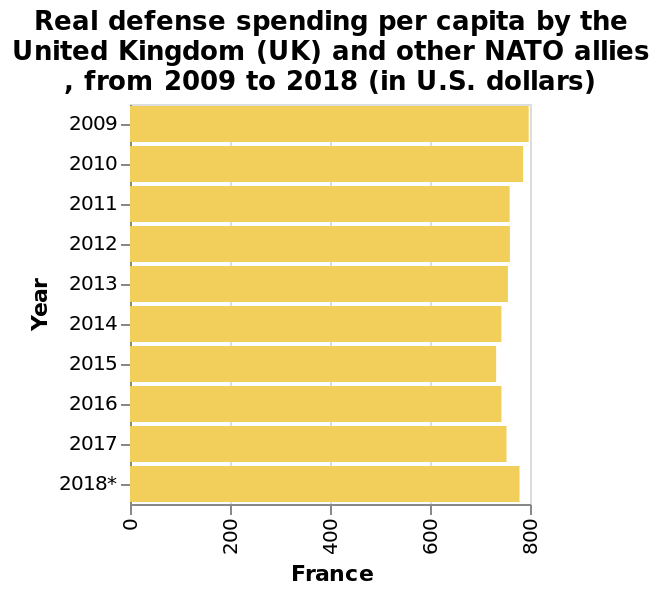<image>
What is the unit of measurement for the real defense spending per capita? The unit of measurement for the real defense spending per capita is U.S. dollars. What was the overall trend of the real defence spending by France between 2009 and 2018? The overall trend of the real defence spending by France between 2009 and 2018 was a gradual decrease followed by a year-on-year increase. What was the approximate amount of the real defence spending by France in 2018? The real defence spending by France in 2018 was nearly 800 dollars. What is measured on the y-axis of the bar plot? The y-axis of the bar plot measures the year. Describe the following image in detail Here a bar plot is titled Real defense spending per capita by the United Kingdom (UK) and other NATO allies , from 2009 to 2018 (in U.S. dollars). The x-axis measures France while the y-axis measures Year. When did the real defence spending by France start to increase after a period of decrease? The real defence spending by France started to increase after a period of decrease from 2009 to 2015. Is a line plot titled Fake defense spending per capita by the United Kingdom (UK) and other NATO allies, from 2009 to 2018 (in U.S. dollars) where the x-axis measures France and the y-axis measures Height? No.Here a bar plot is titled Real defense spending per capita by the United Kingdom (UK) and other NATO allies , from 2009 to 2018 (in U.S. dollars). The x-axis measures France while the y-axis measures Year. 